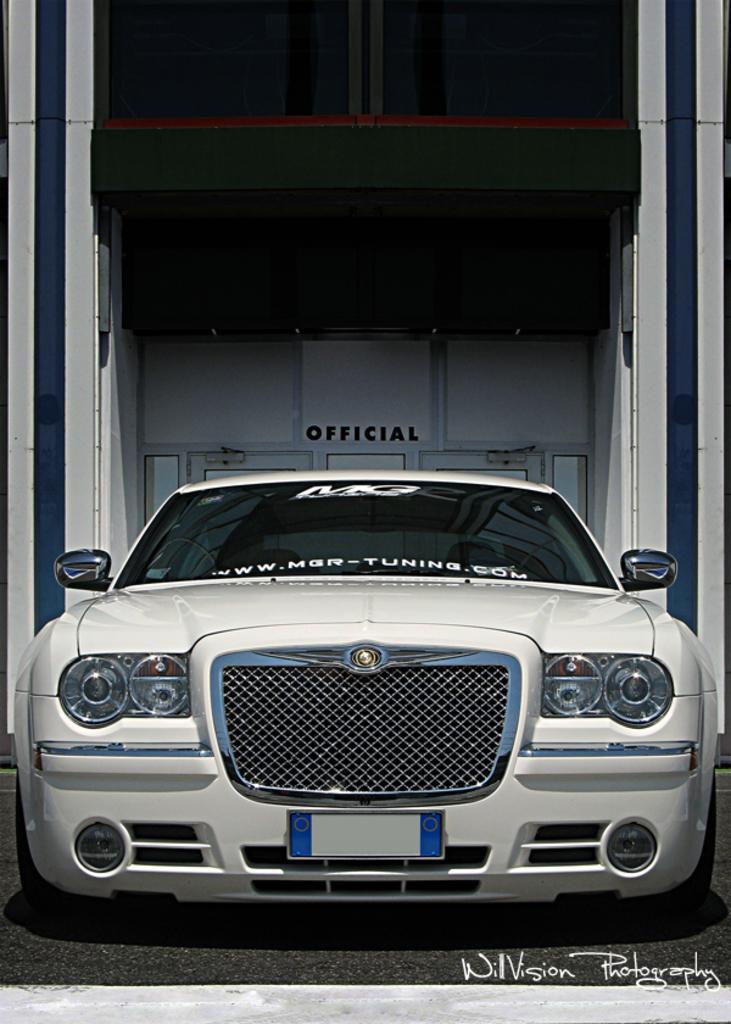In one or two sentences, can you explain what this image depicts? In this picture there is a car which is white in colour in the center. In the background there is a partition and the text official. 